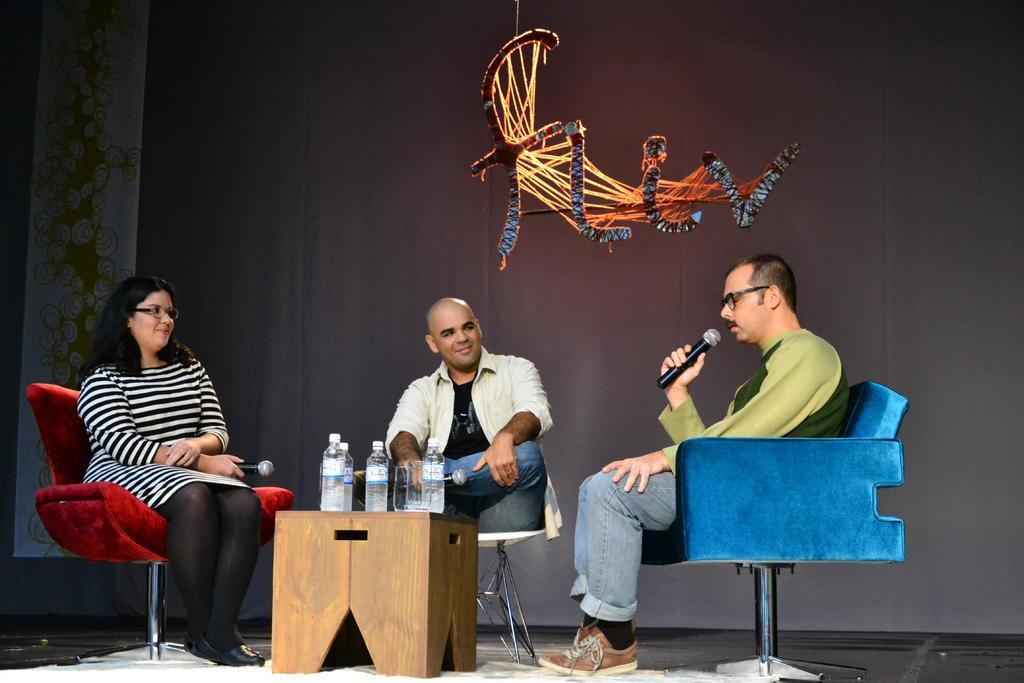How many people are in the image? There are three persons in the image. What are the persons doing in the image? The persons are sitting on chairs and holding miles. What can be seen on the table in the image? There are bottles on the table. What is hanging in the background of the image? There is a showpiece hanging in the background. What type of pin can be seen on the cook's apron in the image? There is no cook or apron present in the image, so it is not possible to determine if there is a pin on the cook's apron. 